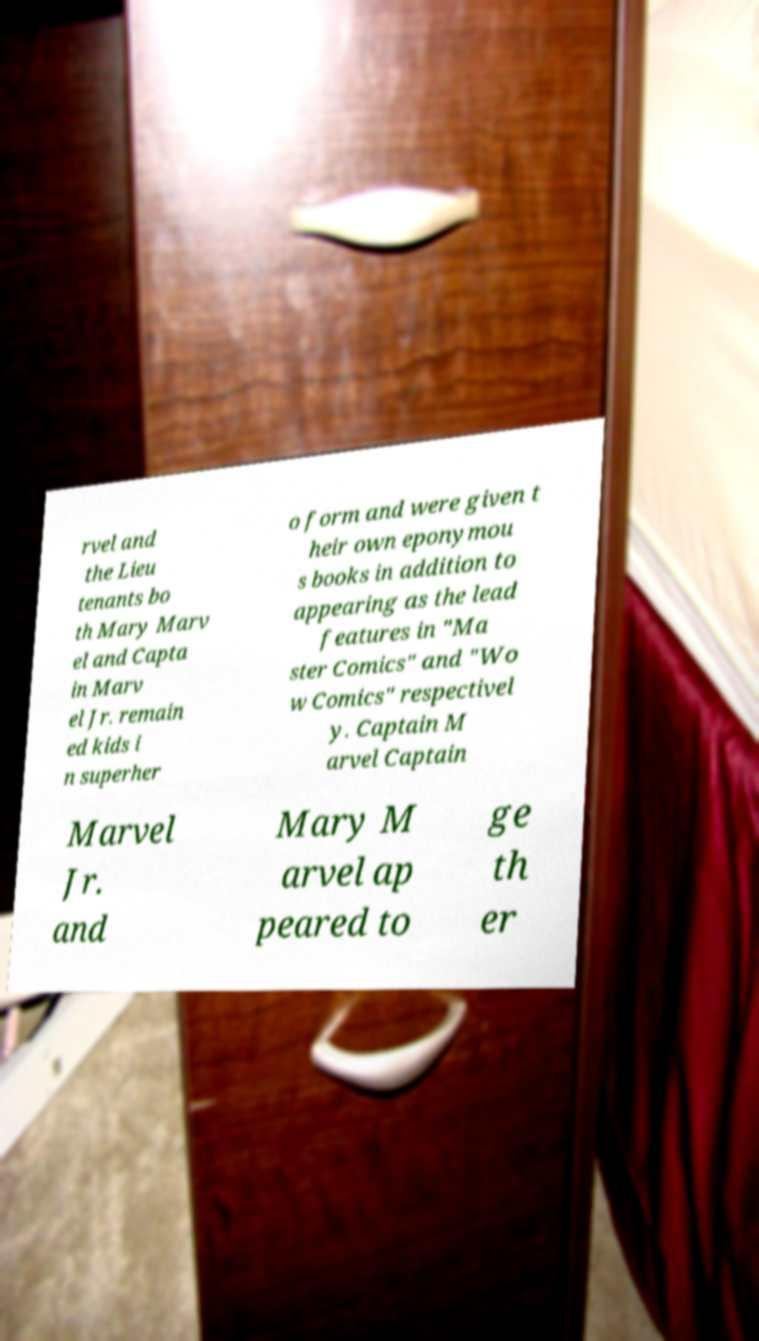Please identify and transcribe the text found in this image. rvel and the Lieu tenants bo th Mary Marv el and Capta in Marv el Jr. remain ed kids i n superher o form and were given t heir own eponymou s books in addition to appearing as the lead features in "Ma ster Comics" and "Wo w Comics" respectivel y. Captain M arvel Captain Marvel Jr. and Mary M arvel ap peared to ge th er 